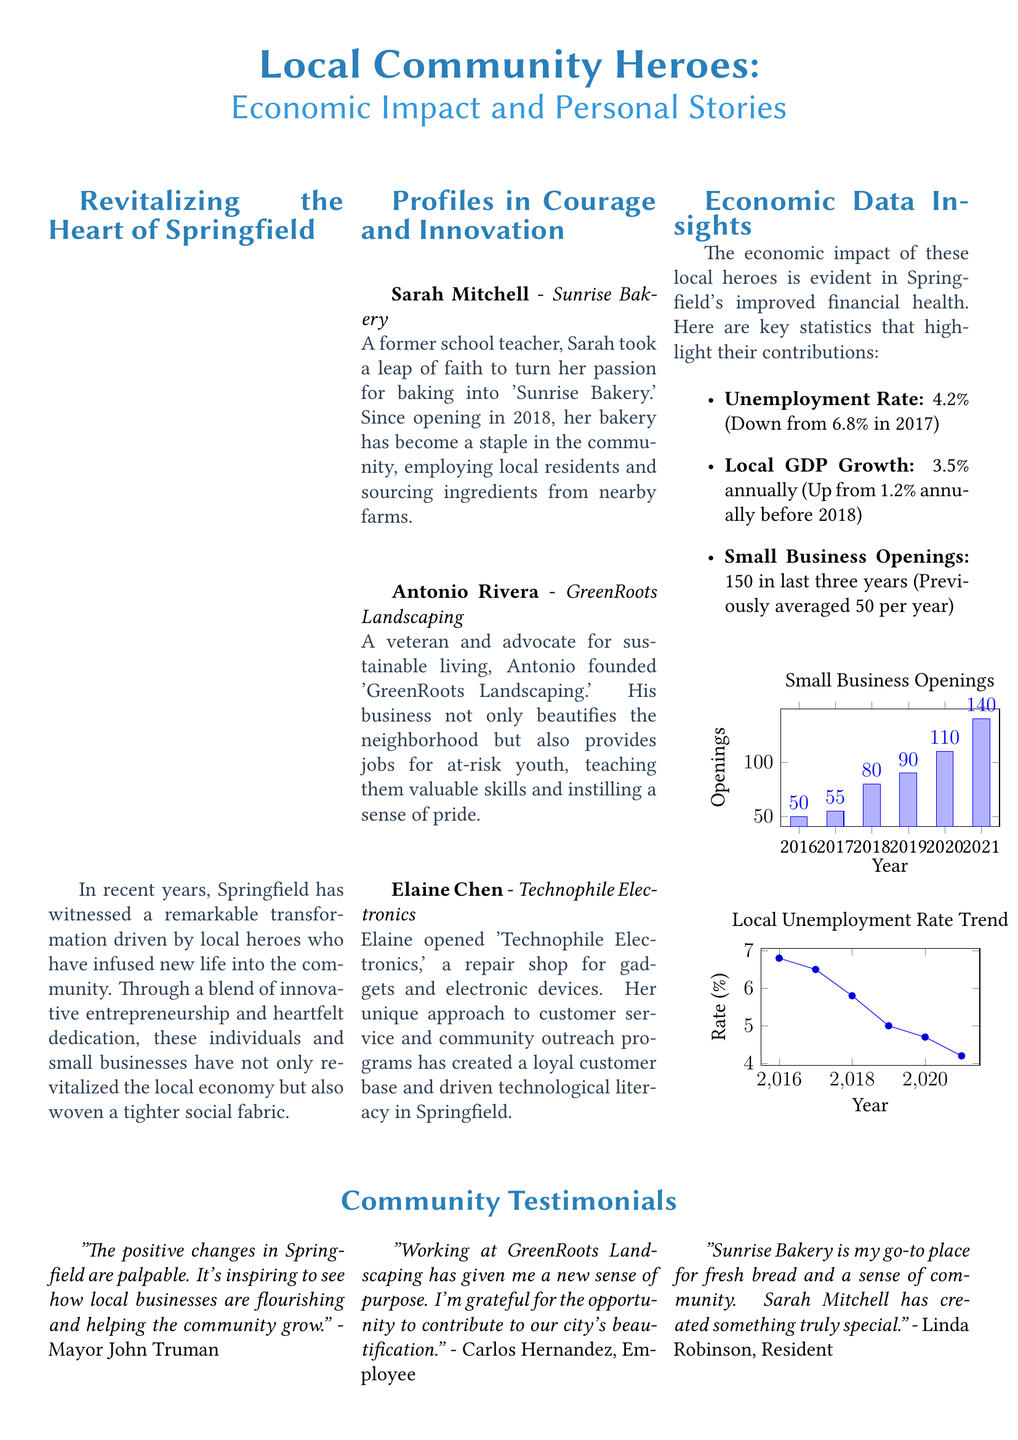What is the name of the bakery owned by Sarah Mitchell? The document mentions 'Sunrise Bakery' as the establishment owned by Sarah Mitchell.
Answer: Sunrise Bakery What year did Sarah Mitchell open her bakery? The document states that Sarah opened her bakery in 2018.
Answer: 2018 What was the unemployment rate in Springfield in 2021? According to the document, the unemployment rate in Springfield in 2021 was 4.2%.
Answer: 4.2% How many small businesses opened in the last three years? The document notes that 150 small businesses have opened in the last three years.
Answer: 150 What is the annual local GDP growth rate mentioned in the document? The document indicates that the local GDP growth rate is 3.5% annually.
Answer: 3.5% Who is the owner of GreenRoots Landscaping? The document identifies Antonio Rivera as the owner of GreenRoots Landscaping.
Answer: Antonio Rivera What does Elaine Chen's business focus on? The document states that Elaine Chen's business, Technophile Electronics, focuses on gadget and electronic device repairs.
Answer: Gadget and electronic device repairs Which community member expressed gratitude for working at GreenRoots Landscaping? Carlos Hernandez is the individual who expressed gratitude for his work at GreenRoots Landscaping in the document.
Answer: Carlos Hernandez What color scheme is used for headings in the document? The headings are colored with the RGB value of 41,128,185, identified as headingcolor in the document.
Answer: RGB(41,128,185) 